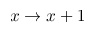<formula> <loc_0><loc_0><loc_500><loc_500>x \rightarrow x + 1</formula> 